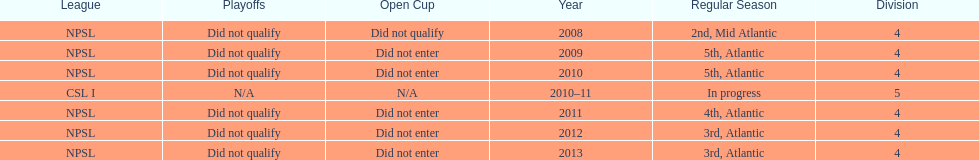What are the leagues? NPSL, NPSL, NPSL, CSL I, NPSL, NPSL, NPSL. Of these, what league is not npsl? CSL I. 